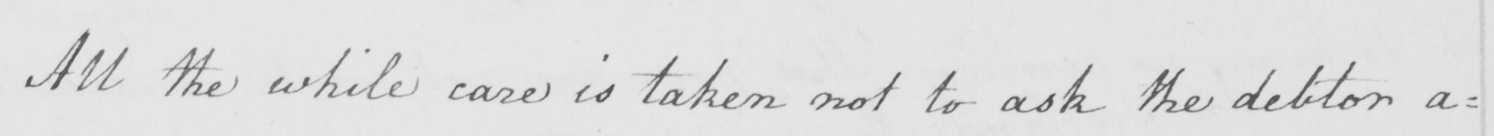What is written in this line of handwriting? All the while care is taken not to ask the debtor a= 